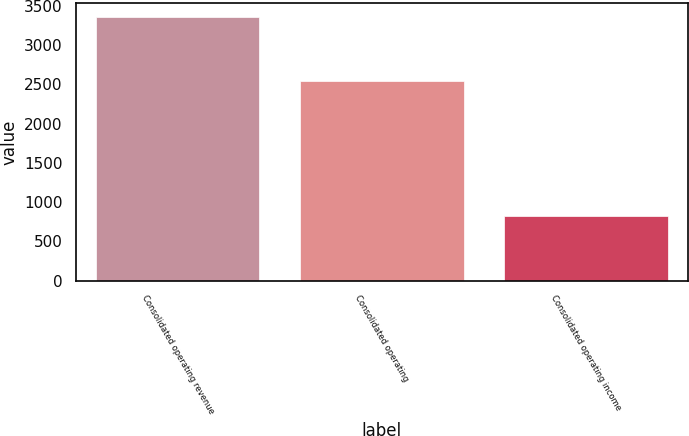<chart> <loc_0><loc_0><loc_500><loc_500><bar_chart><fcel>Consolidated operating revenue<fcel>Consolidated operating<fcel>Consolidated operating income<nl><fcel>3362.2<fcel>2537.6<fcel>824.6<nl></chart> 